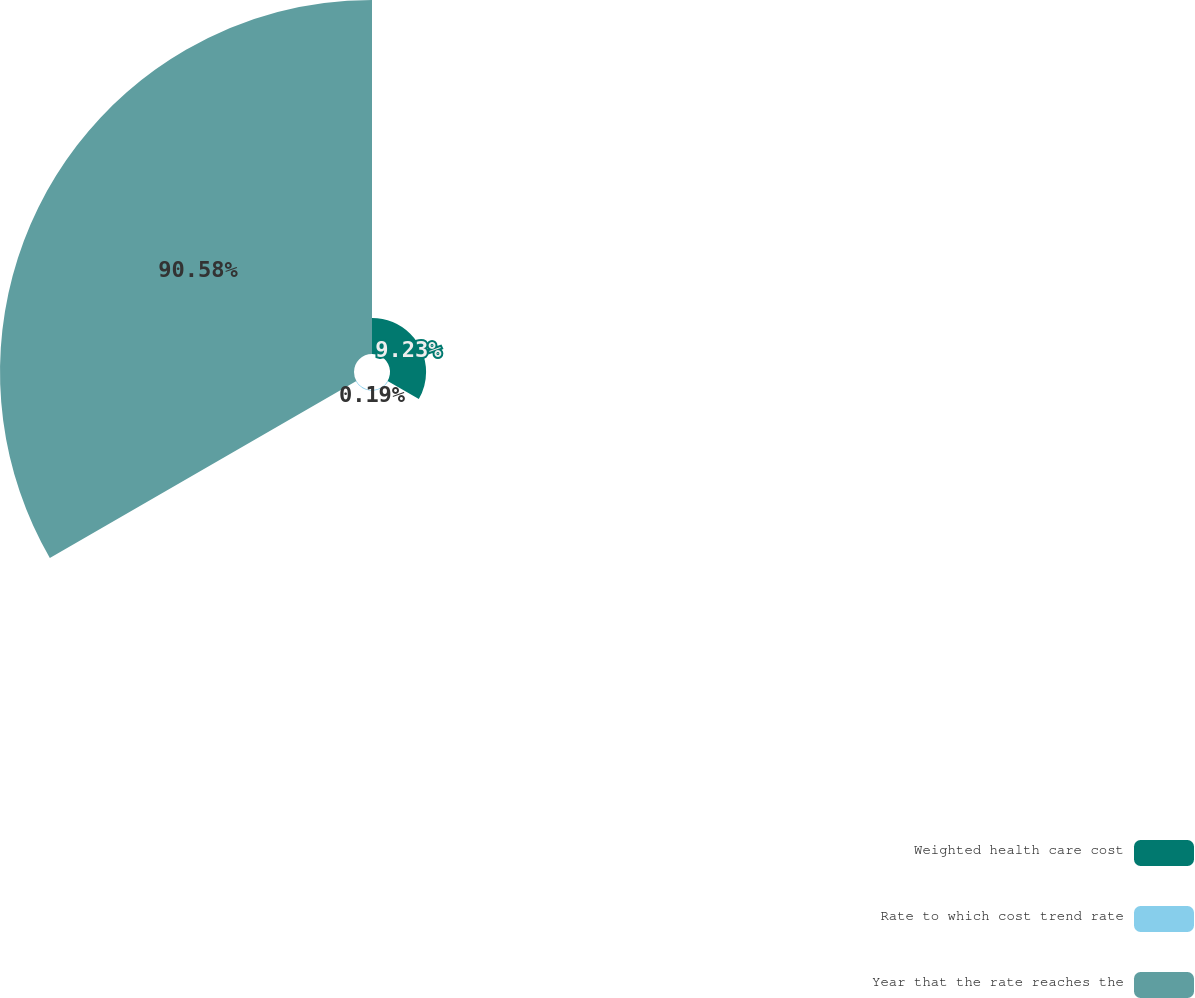Convert chart. <chart><loc_0><loc_0><loc_500><loc_500><pie_chart><fcel>Weighted health care cost<fcel>Rate to which cost trend rate<fcel>Year that the rate reaches the<nl><fcel>9.23%<fcel>0.19%<fcel>90.57%<nl></chart> 